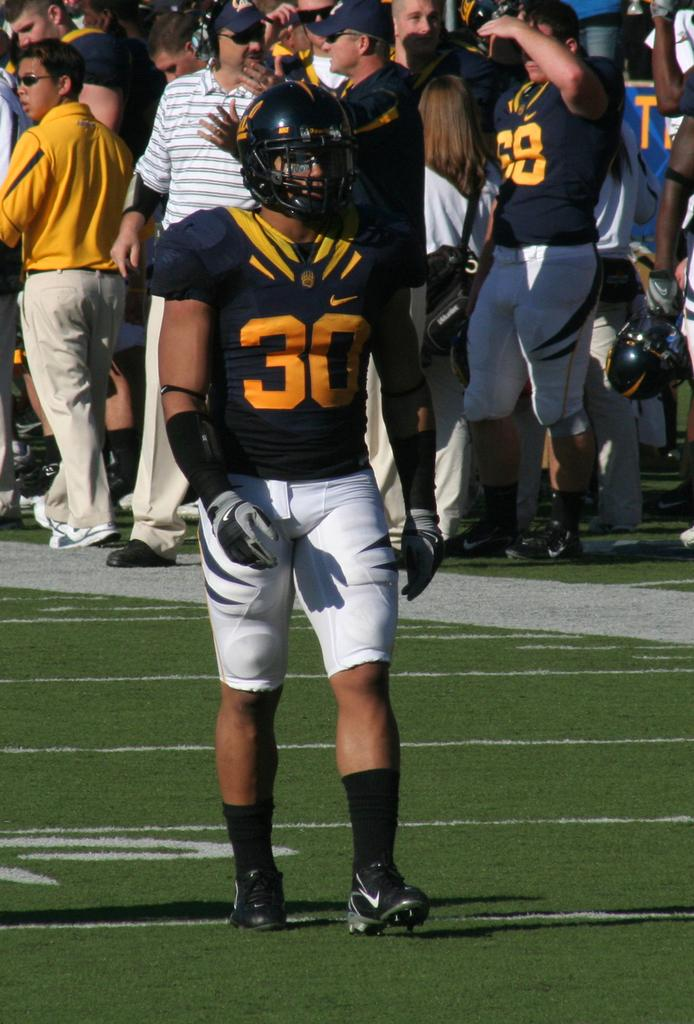What is the person in the image doing? The person in the image is walking. What protective gear is the person wearing? The person is wearing a helmet. What color is the person's t-shirt? The person is wearing a black t-shirt. What type of clothing is the person wearing on their hands? The person is wearing gloves. What type of clothing is the person wearing on their lower body? The person is wearing white shorts. How many people are visible behind the person walking? There are many people standing behind the person. What type of flesh can be seen on the person's face in the image? There is no flesh visible on the person's face in the image, as the person is wearing a helmet. How many cherries are being held by the person in the image? There are no cherries present in the image. 